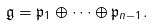<formula> <loc_0><loc_0><loc_500><loc_500>\mathfrak { g } = \mathfrak { p } _ { 1 } \oplus \dots \oplus \mathfrak { p } _ { n - 1 } .</formula> 